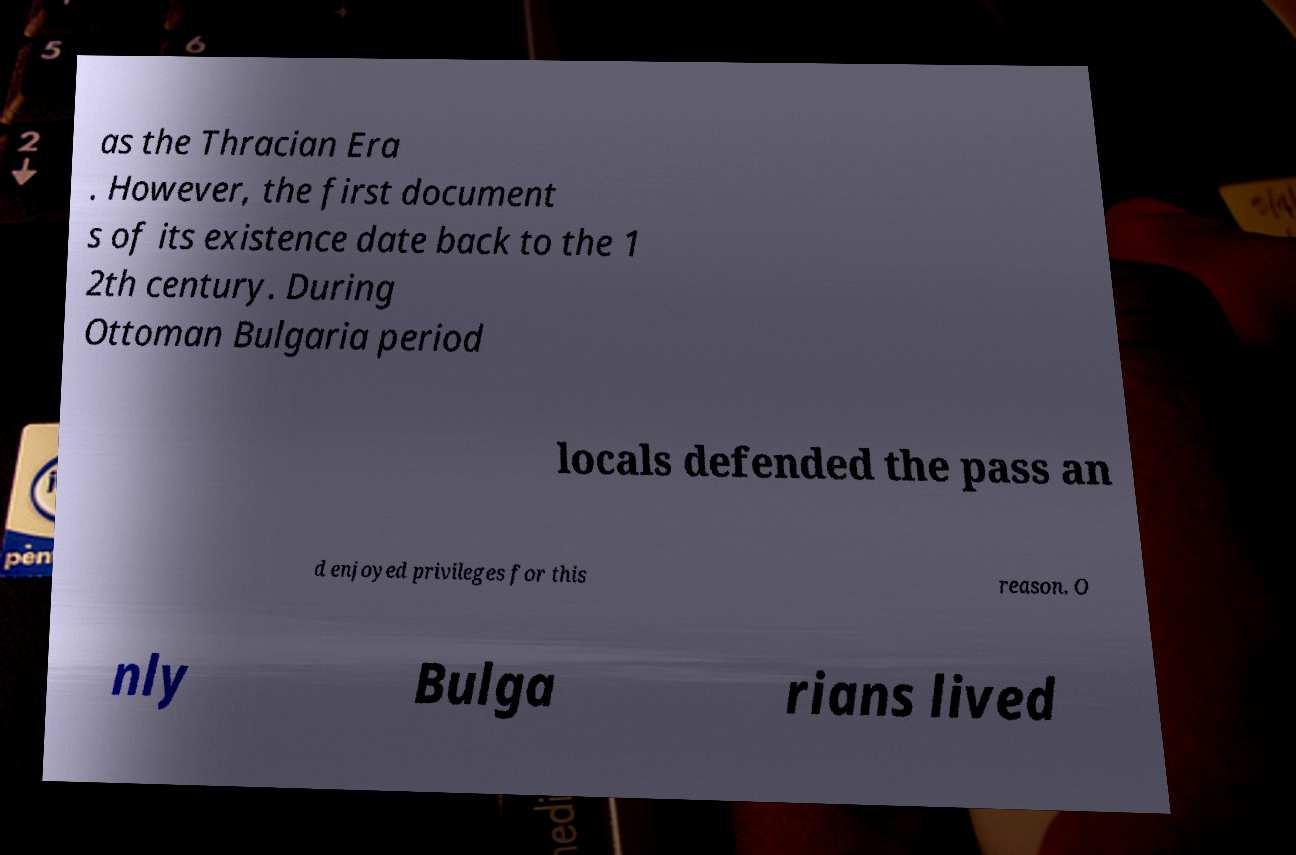Please read and relay the text visible in this image. What does it say? The text in the image says: 'as the Thracian Era. However, the first documents of its existence date back to the 12th century. During the Ottoman Bulgaria period, locals defended the pass and enjoyed privileges for this reason. Only Bulgarians lived.' 